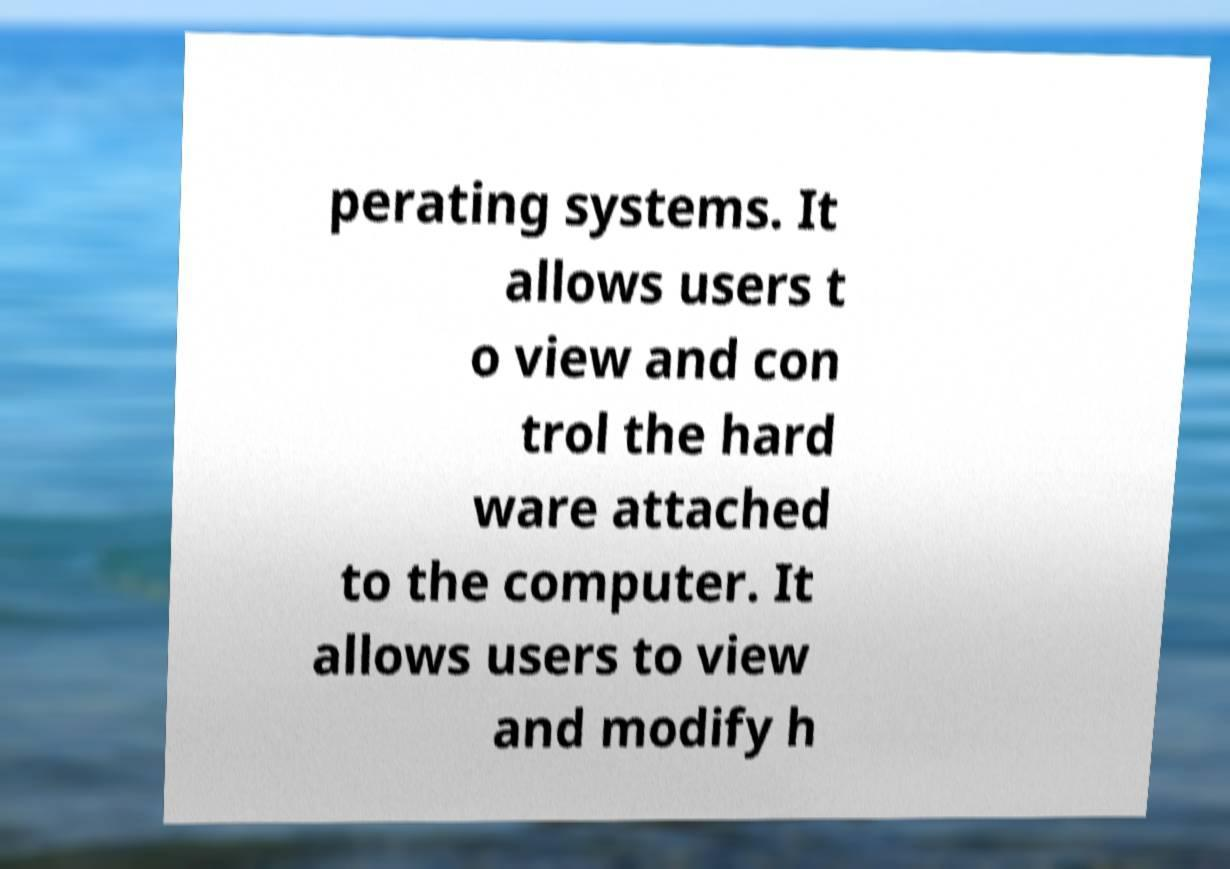Could you extract and type out the text from this image? perating systems. It allows users t o view and con trol the hard ware attached to the computer. It allows users to view and modify h 